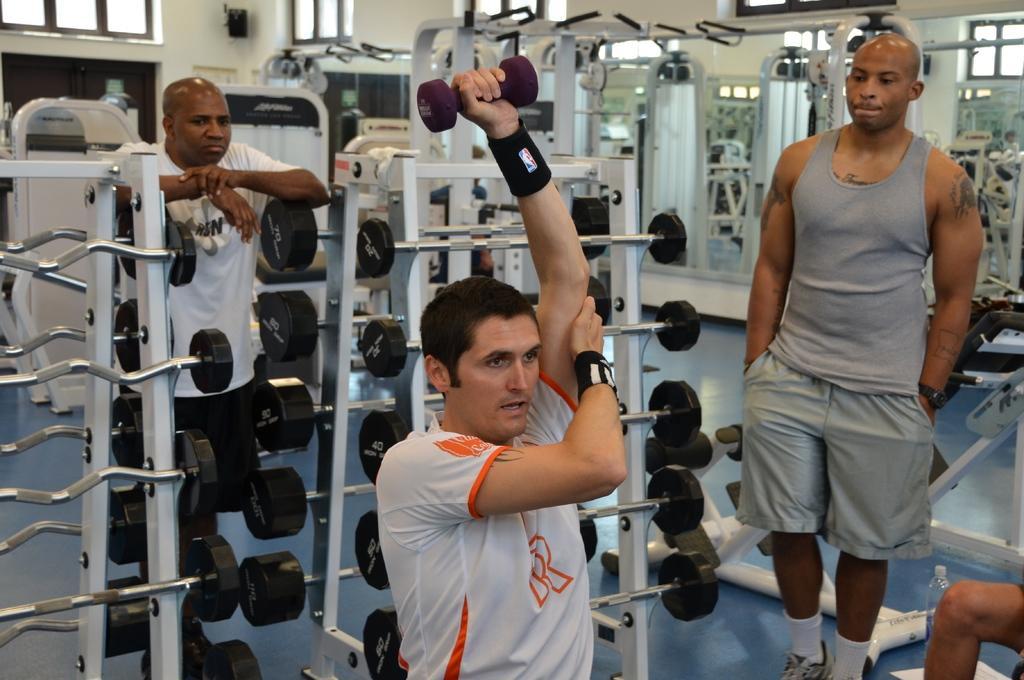How would you summarize this image in a sentence or two? In this picture I can see there is a man he is wearing a white shirt and he is holding dumbbell in his left hand and there are two other people watching him. 